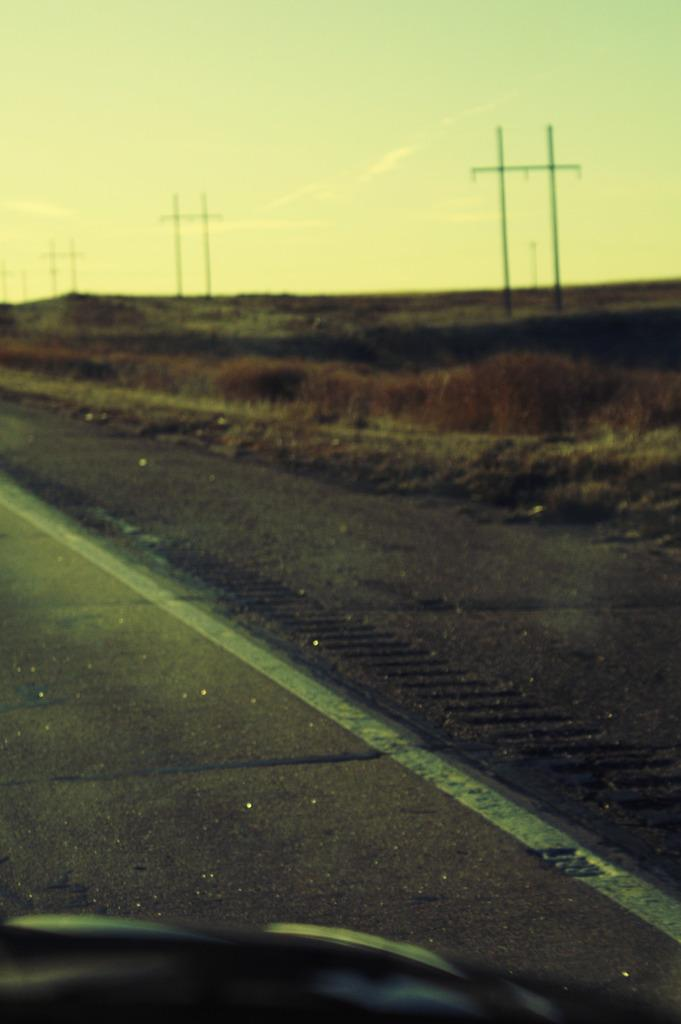What is located on the left side of the image? There is a road on the left side of the image. What can be seen behind the road? The land behind the road is covered with dry grass and plants. What structures are present in the middle of the image? There are electric poles in the middle of the image. What is visible in the image besides the road and electric poles? The sky is visible in the image, and clouds are present in the sky. What type of cheese is being used to build the electric poles in the image? There is no cheese present in the image, and the electric poles are not being built. How many cattle can be seen grazing on the dry grass in the image? There are no cattle present in the image; the land is covered with dry grass and plants. 